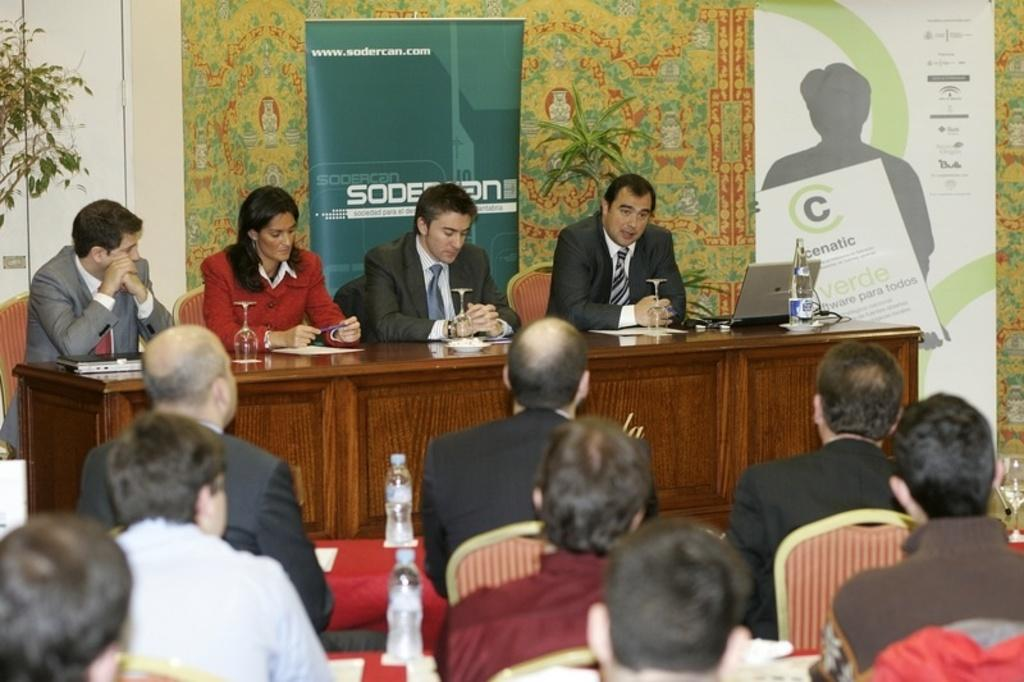How many people are in the image? There is a group of people in the image. What are the people doing in the image? The people are sitting on chairs. What is in front of the people? There is a table in front of the people. What items can be seen on the table? There is a bottle, glasses, and a laptop on the table. What can be seen in the background of the image? There are banners and a plant in the background of the image. What type of beef is being served on the table in the image? There is no beef present in the image; the table contains a bottle, glasses, and a laptop. Can you tell me how many rabbits are sitting with the people in the image? There are no rabbits present in the image; the people are sitting on chairs. 